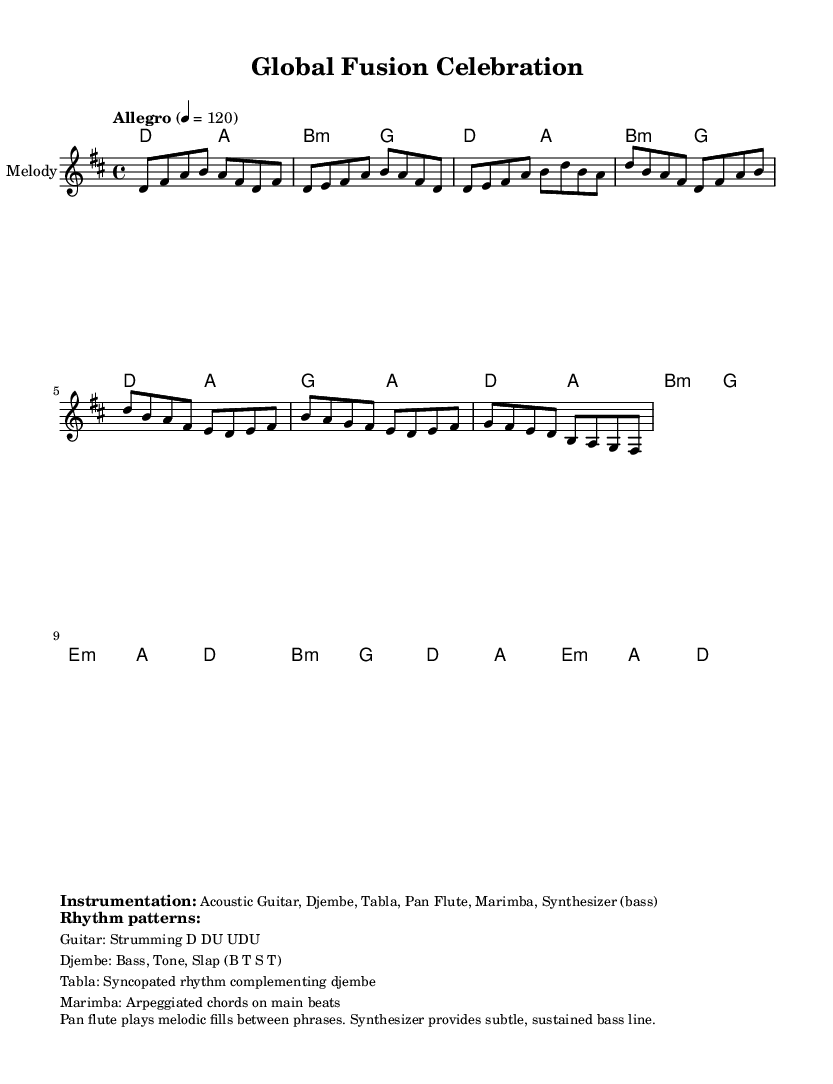What is the key signature of this music? The key signature is D major, which has two sharps (F# and C#).
Answer: D major What is the time signature of this music? The time signature is 4/4, indicating four beats per measure.
Answer: 4/4 What is the tempo marking for this piece? The tempo marking indicates an Allegro pace, set at 120 beats per minute.
Answer: Allegro, 120 How many instruments are mentioned in the instrumentation section? The instrumentation section lists six instruments: Acoustic Guitar, Djembe, Tabla, Pan Flute, Marimba, and Synthesizer.
Answer: Six What rhythm pattern is used for the acoustic guitar? The pattern for the acoustic guitar is specified as Strumming D DU UDU, which provides a driving rhythm.
Answer: D DU UDU What is the harmonic structure used in the introduction? The introduction consists of D and A chords followed by B minor and G, creating a rich harmonic backdrop.
Answer: D, A, B minor, G What specific elements does the pan flute contribute between phrases? The pan flute plays melodic fills, enhancing the texture and richness of the music by adding melodic interest.
Answer: Melodic fills 